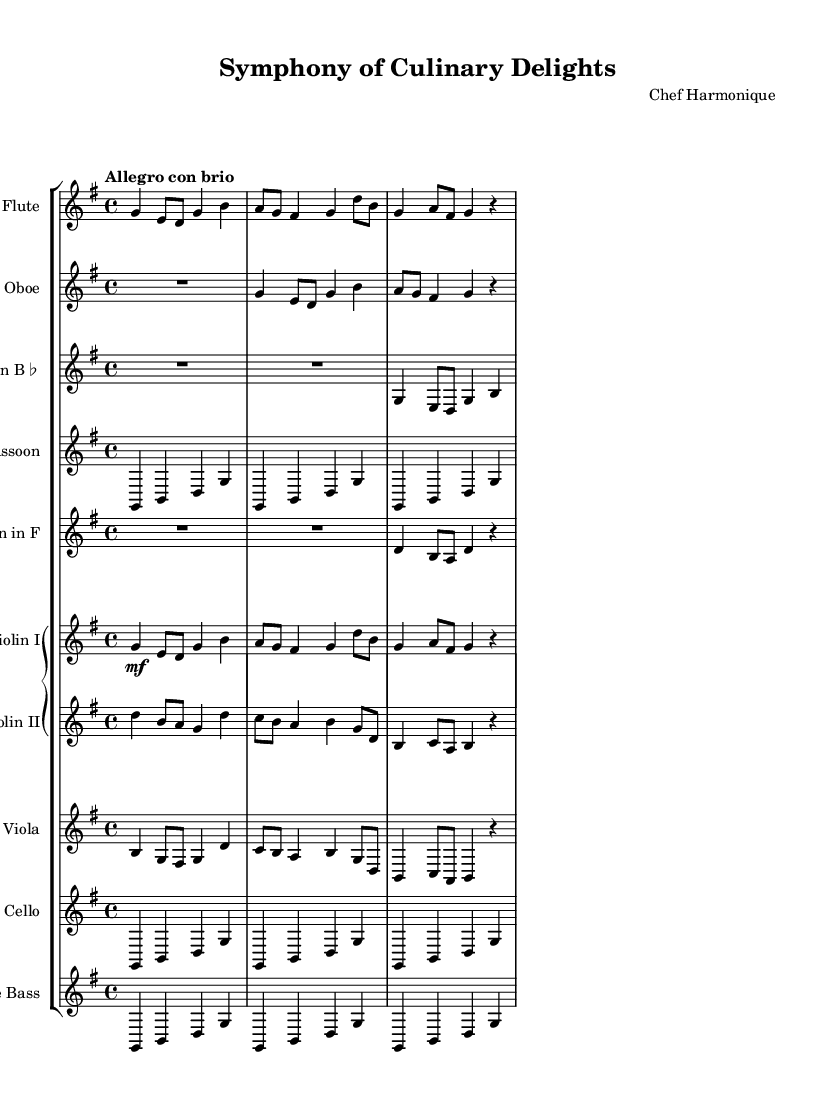What is the key signature of this music? The key signature indicated in the global settings shows that it is G major, which has one sharp (F#).
Answer: G major What is the time signature of this music? The time signature specified is 4/4, which means there are four beats in a measure and a quarter note gets one beat.
Answer: 4/4 What is the tempo marking of this piece? The tempo marking states "Allegro con brio," which indicates a lively and energetic pace, typically faster than 120 beats per minute.
Answer: Allegro con brio How many instruments are in this symphony? The score displays a total of 10 instruments, including woodwinds, brass, strings, and bass instruments.
Answer: 10 Which instrument plays the melody in the first two measures? The melody in the first two measures is primarily played by the Flute, which has the main theme presented at the start.
Answer: Flute How many times is the note G played in the first section for the Violin I? In the first section for Violin I, the note G is played four times throughout the stated measures.
Answer: 4 times Is there a rest indicated in the music? If so, where? Yes, a rest is indicated after certain notes, particularly at the end of measure four for the Flute and Oboe, allowing for a brief silence.
Answer: Yes 